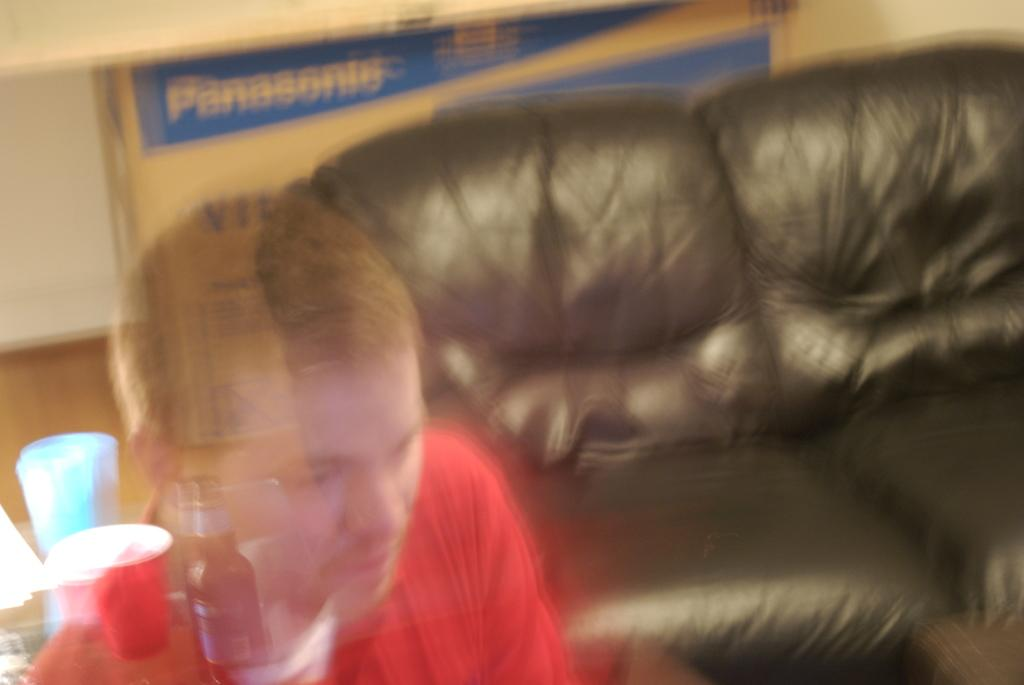Who is present in the image? There is a person in the image. What is the person wearing? The person is wearing a red t-shirt. What object can be seen in the image besides the person? There is a bottle in the image. What type of furniture is visible in the background of the image? There is a back couch in the background of the image. What other object can be seen in the background of the image? There is a box in the background of the image. How many cacti are present in the image? There are no cacti present in the image. What type of cap is the person wearing in the image? The person is not wearing a cap in the image; they are wearing a red t-shirt. 